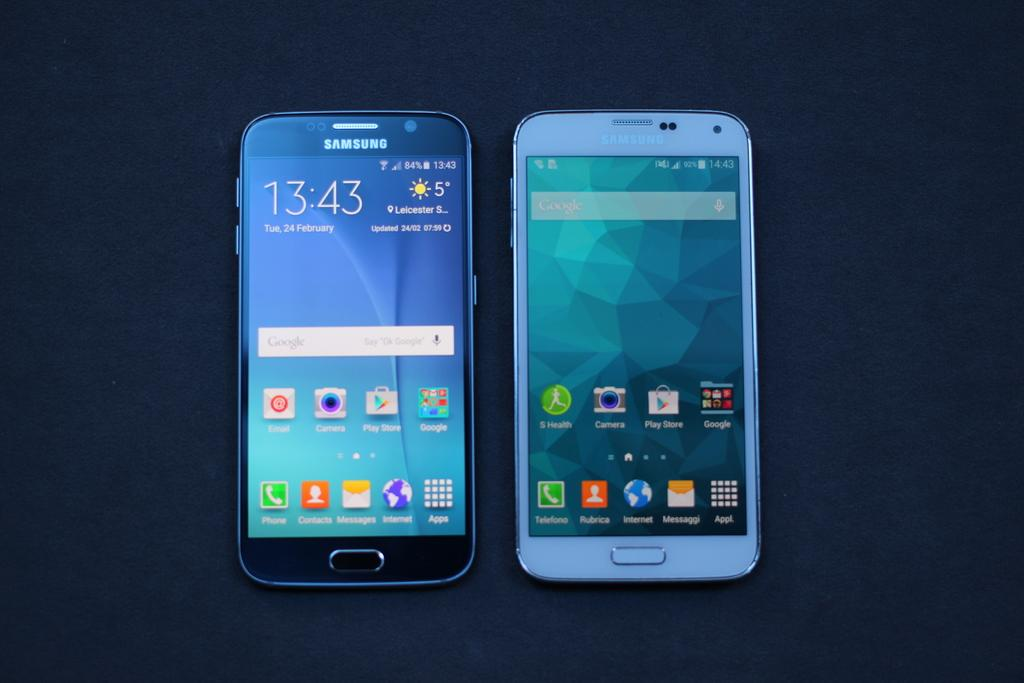<image>
Give a short and clear explanation of the subsequent image. a phone with the word messages on it 